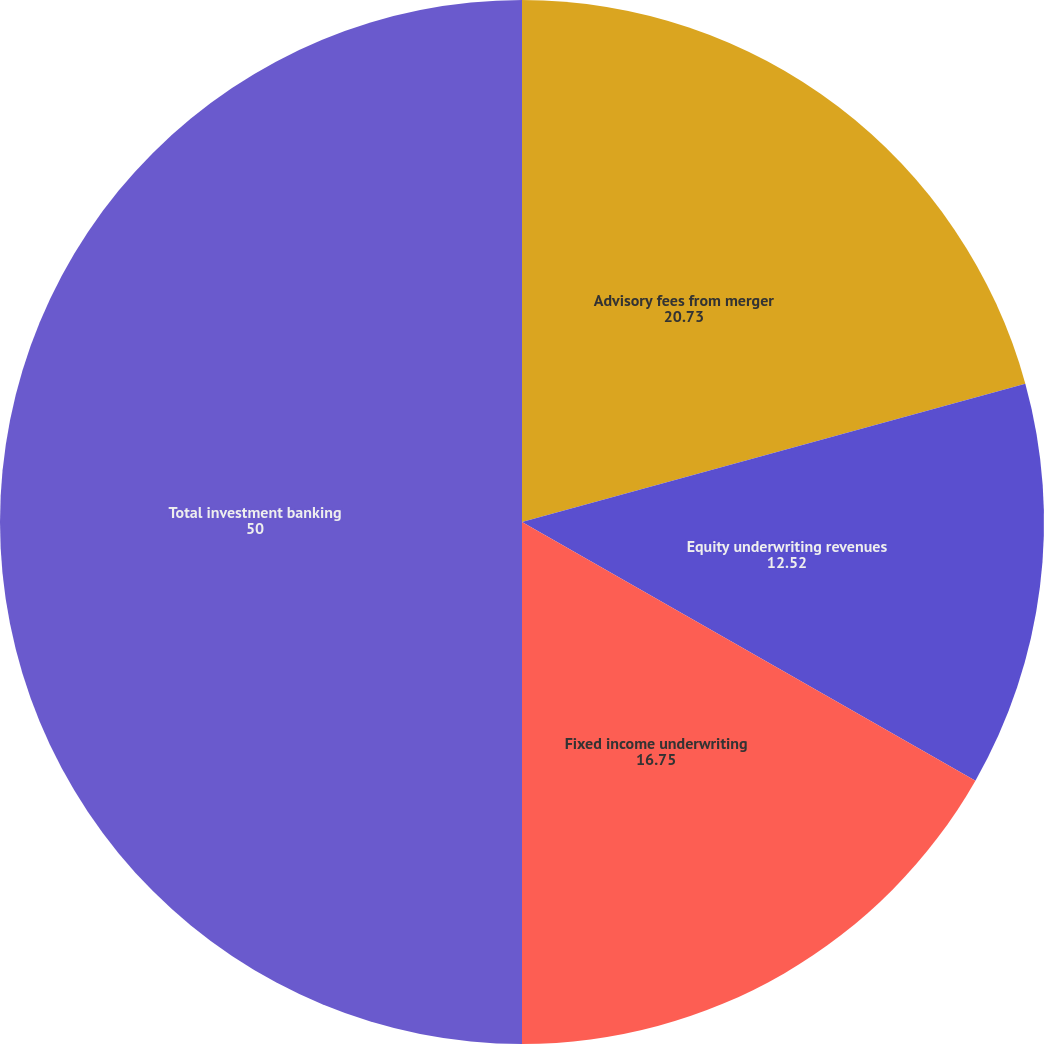Convert chart to OTSL. <chart><loc_0><loc_0><loc_500><loc_500><pie_chart><fcel>Advisory fees from merger<fcel>Equity underwriting revenues<fcel>Fixed income underwriting<fcel>Total investment banking<nl><fcel>20.73%<fcel>12.52%<fcel>16.75%<fcel>50.0%<nl></chart> 